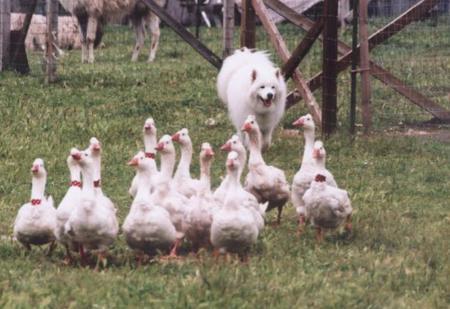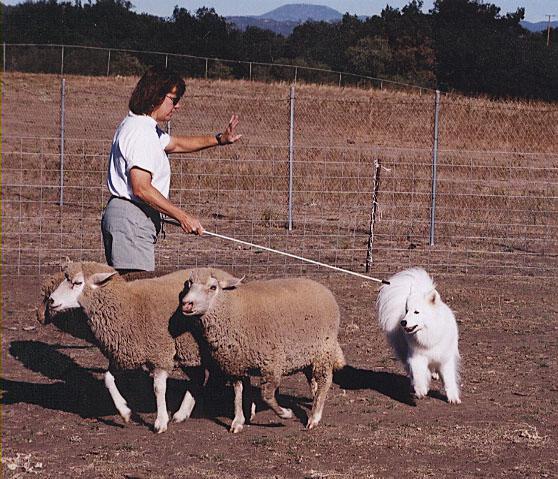The first image is the image on the left, the second image is the image on the right. Considering the images on both sides, is "There is a woman standing and facing right." valid? Answer yes or no. Yes. The first image is the image on the left, the second image is the image on the right. Assess this claim about the two images: "In one image, a dog is with a person and sheep.". Correct or not? Answer yes or no. Yes. 